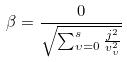<formula> <loc_0><loc_0><loc_500><loc_500>\beta = \frac { 0 } { \sqrt { \sum _ { \upsilon = 0 } ^ { s } \frac { j ^ { 2 } } { v _ { \upsilon } ^ { 2 } } } }</formula> 